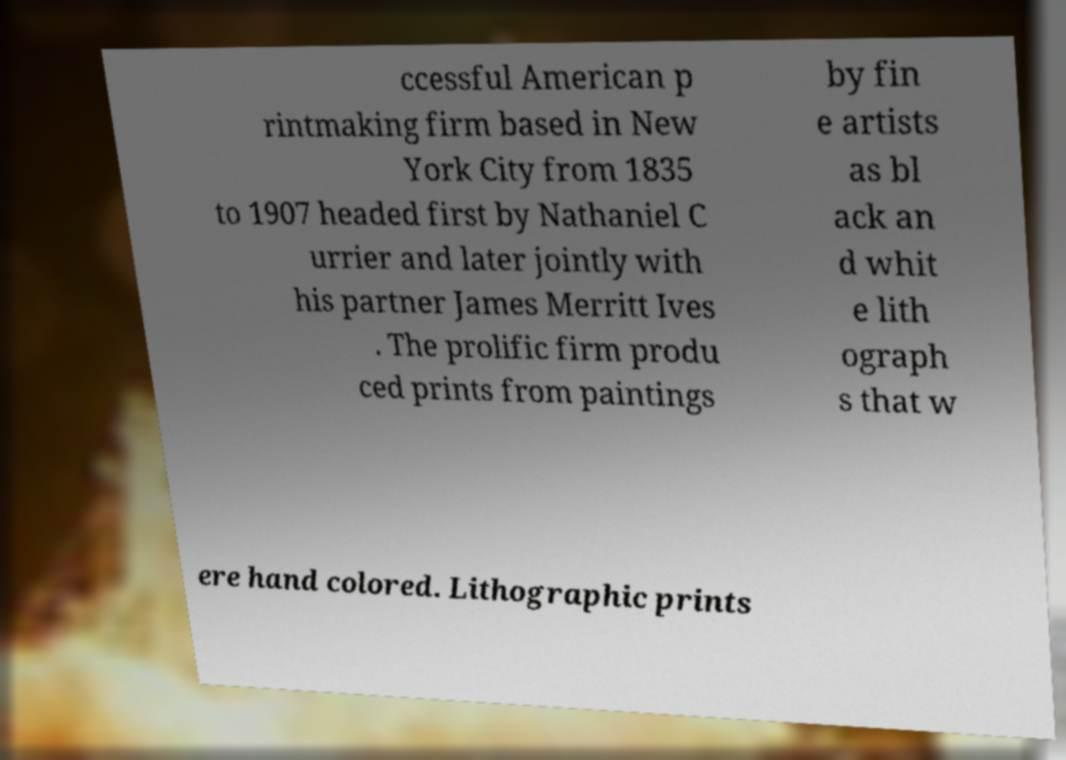There's text embedded in this image that I need extracted. Can you transcribe it verbatim? ccessful American p rintmaking firm based in New York City from 1835 to 1907 headed first by Nathaniel C urrier and later jointly with his partner James Merritt Ives . The prolific firm produ ced prints from paintings by fin e artists as bl ack an d whit e lith ograph s that w ere hand colored. Lithographic prints 